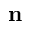Convert formula to latex. <formula><loc_0><loc_0><loc_500><loc_500>n</formula> 